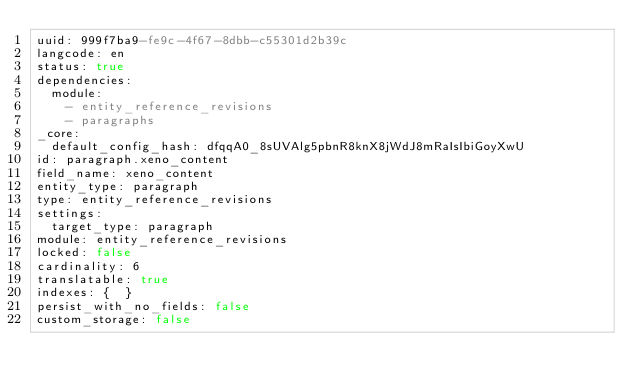Convert code to text. <code><loc_0><loc_0><loc_500><loc_500><_YAML_>uuid: 999f7ba9-fe9c-4f67-8dbb-c55301d2b39c
langcode: en
status: true
dependencies:
  module:
    - entity_reference_revisions
    - paragraphs
_core:
  default_config_hash: dfqqA0_8sUVAlg5pbnR8knX8jWdJ8mRaIsIbiGoyXwU
id: paragraph.xeno_content
field_name: xeno_content
entity_type: paragraph
type: entity_reference_revisions
settings:
  target_type: paragraph
module: entity_reference_revisions
locked: false
cardinality: 6
translatable: true
indexes: {  }
persist_with_no_fields: false
custom_storage: false
</code> 